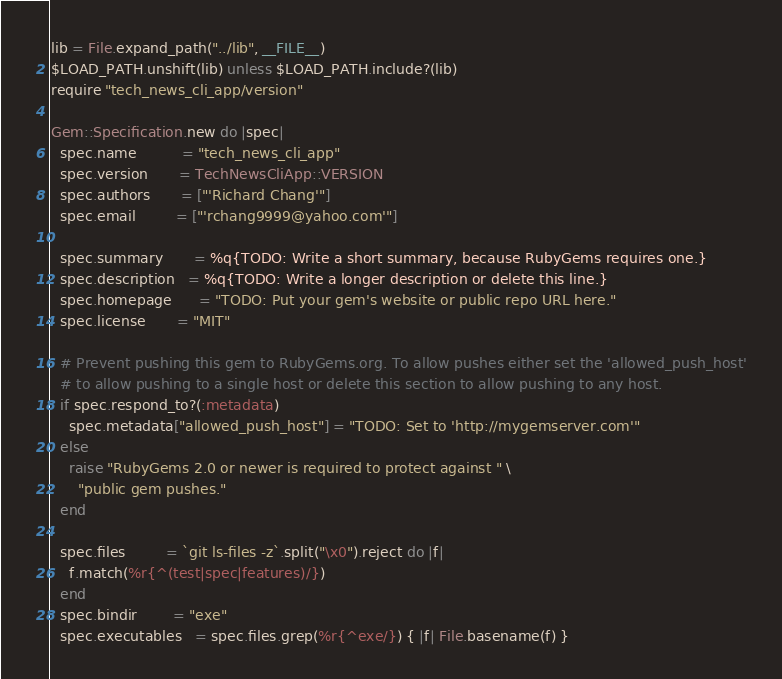Convert code to text. <code><loc_0><loc_0><loc_500><loc_500><_Ruby_>
lib = File.expand_path("../lib", __FILE__)
$LOAD_PATH.unshift(lib) unless $LOAD_PATH.include?(lib)
require "tech_news_cli_app/version"

Gem::Specification.new do |spec|
  spec.name          = "tech_news_cli_app"
  spec.version       = TechNewsCliApp::VERSION
  spec.authors       = ["'Richard Chang'"]
  spec.email         = ["'rchang9999@yahoo.com'"]

  spec.summary       = %q{TODO: Write a short summary, because RubyGems requires one.}
  spec.description   = %q{TODO: Write a longer description or delete this line.}
  spec.homepage      = "TODO: Put your gem's website or public repo URL here."
  spec.license       = "MIT"

  # Prevent pushing this gem to RubyGems.org. To allow pushes either set the 'allowed_push_host'
  # to allow pushing to a single host or delete this section to allow pushing to any host.
  if spec.respond_to?(:metadata)
    spec.metadata["allowed_push_host"] = "TODO: Set to 'http://mygemserver.com'"
  else
    raise "RubyGems 2.0 or newer is required to protect against " \
      "public gem pushes."
  end

  spec.files         = `git ls-files -z`.split("\x0").reject do |f|
    f.match(%r{^(test|spec|features)/})
  end
  spec.bindir        = "exe"
  spec.executables   = spec.files.grep(%r{^exe/}) { |f| File.basename(f) }</code> 